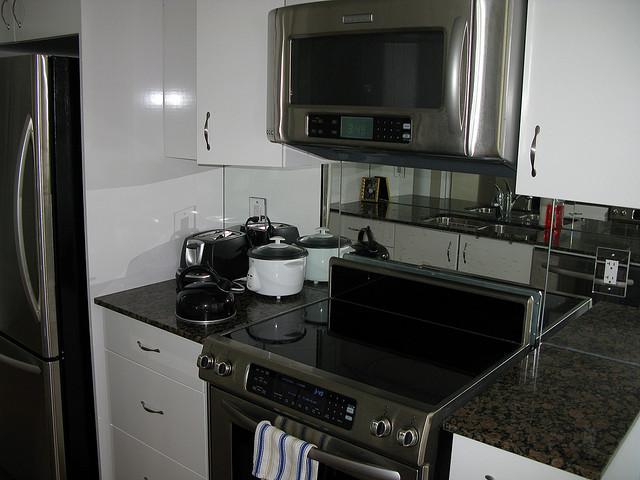What color is the teapot?
Quick response, please. Black. How many towels are hanging?
Write a very short answer. 1. How many burners are on the stove?
Keep it brief. 4. What is the color of the stove?
Answer briefly. Black. Where is the electrical outlet?
Answer briefly. Left side wall. What color are these appliances?
Keep it brief. Silver. Is the stove silver?
Write a very short answer. Yes. What appliance is in the corner?
Quick response, please. Toaster. What is hanging on the oven door?
Be succinct. Towel. Where is the tea kettle?
Write a very short answer. Counter. What side of the stove is the toast on?
Write a very short answer. Left. 